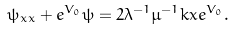<formula> <loc_0><loc_0><loc_500><loc_500>\psi _ { x x } + e ^ { V _ { 0 } } \psi = 2 \lambda ^ { - 1 } \mu ^ { - 1 } k x e ^ { V _ { 0 } } .</formula> 